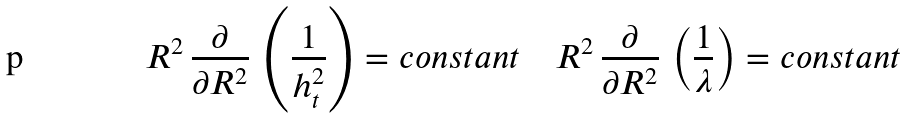<formula> <loc_0><loc_0><loc_500><loc_500>R ^ { 2 } \, \frac { \partial } { \partial R ^ { 2 } } \, \left ( \frac { 1 } { h ^ { 2 } _ { t } } \right ) = c o n s t a n t \quad R ^ { 2 } \, \frac { \partial } { \partial R ^ { 2 } } \, \left ( \frac { 1 } { \lambda } \right ) = c o n s t a n t</formula> 